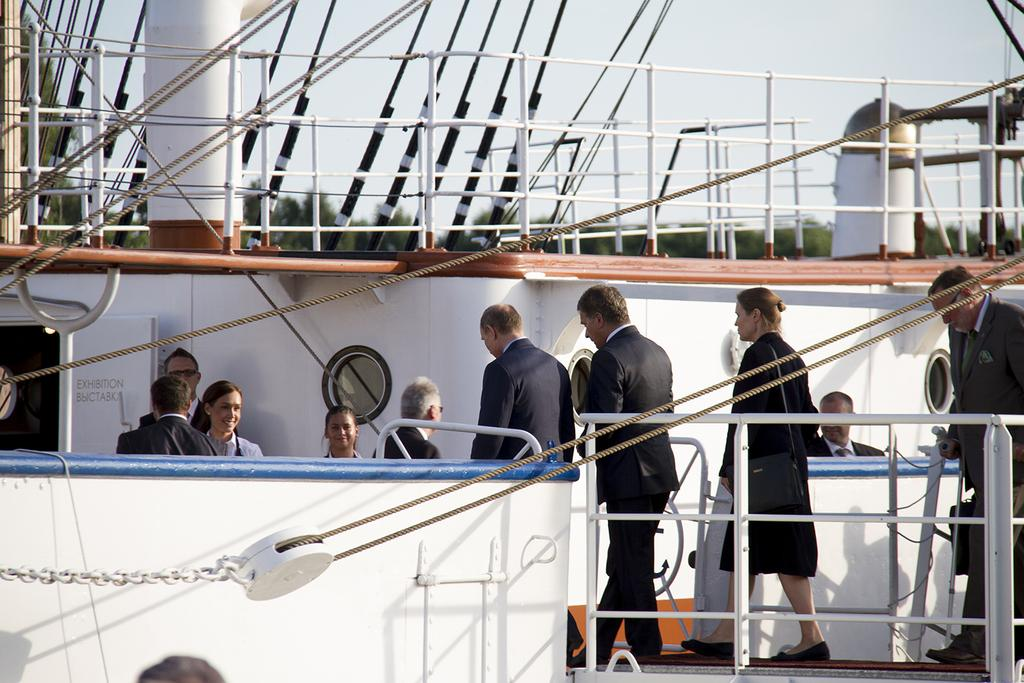What is the main subject of the image? The main subject of the image is a ship. Are there any people on the ship? Yes, there are people in the ship. What can be seen in the background of the image? The sky and trees are visible in the background of the image. What is the purpose of the form that is being smashed in the image? There is no form being smashed in the image; it features a ship with people on it and a background of sky and trees. 